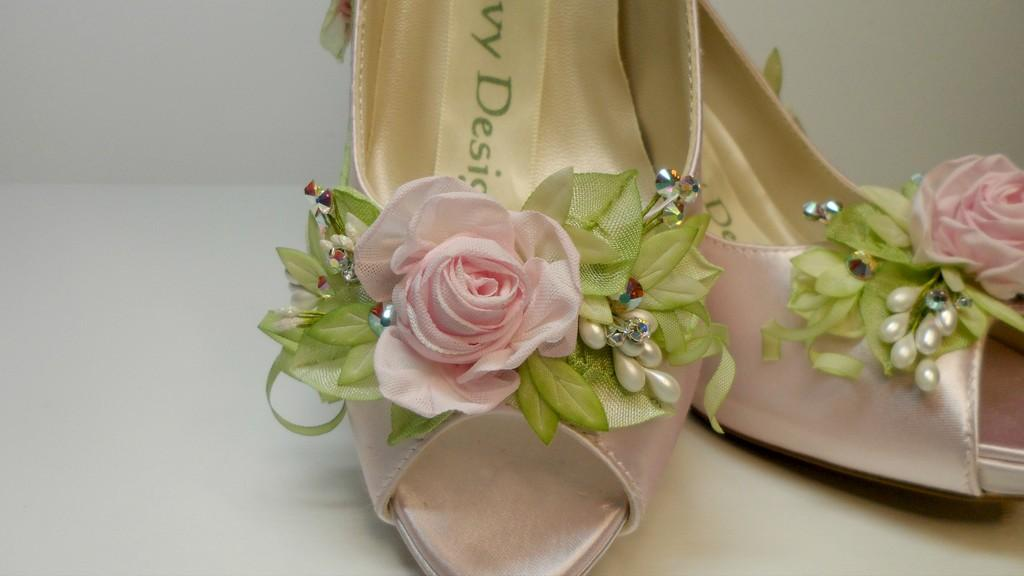What type of footwear is featured in the image? There is a pair of heels in the image. What decorative elements are present on the heels? The heels have pearls on them. What other decorative items can be seen in the image? There are artificial flowers and leaves in the image. What is the color of the background in the image? The background of the image is white. Can you tell me how many volcanoes are visible in the image? There are no volcanoes present in the image. What type of drum is being played in the image? There is no drum present in the image. 